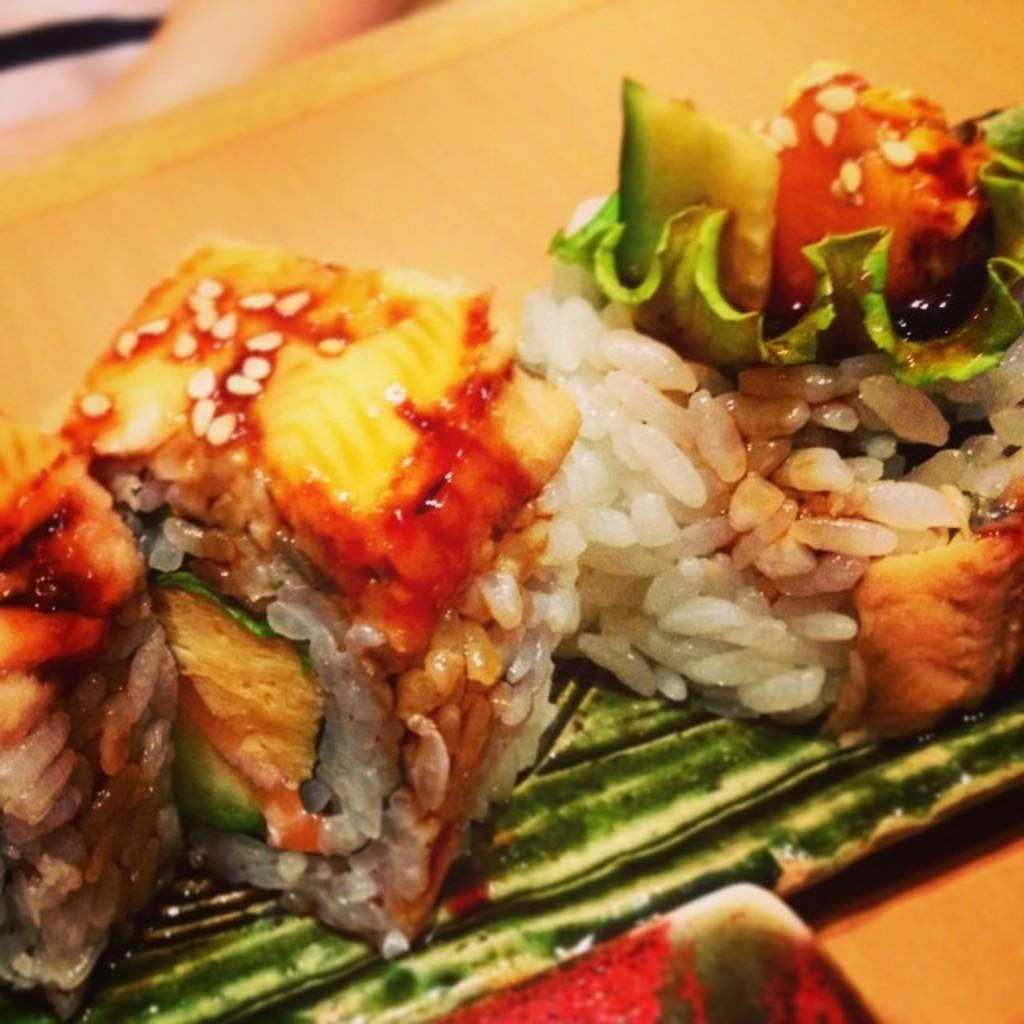What is present on the platform in the image? There is food on a platform in the image. What type of waves can be seen crashing on the shore in the image? There are no waves or shore visible in the image; it only features food on a platform. 